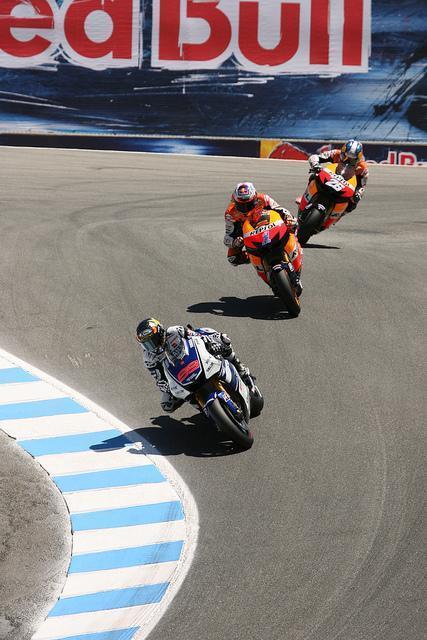How many motorcycles are there?
Give a very brief answer. 3. How many motorcycles can you see?
Give a very brief answer. 3. How many people are there?
Give a very brief answer. 2. 